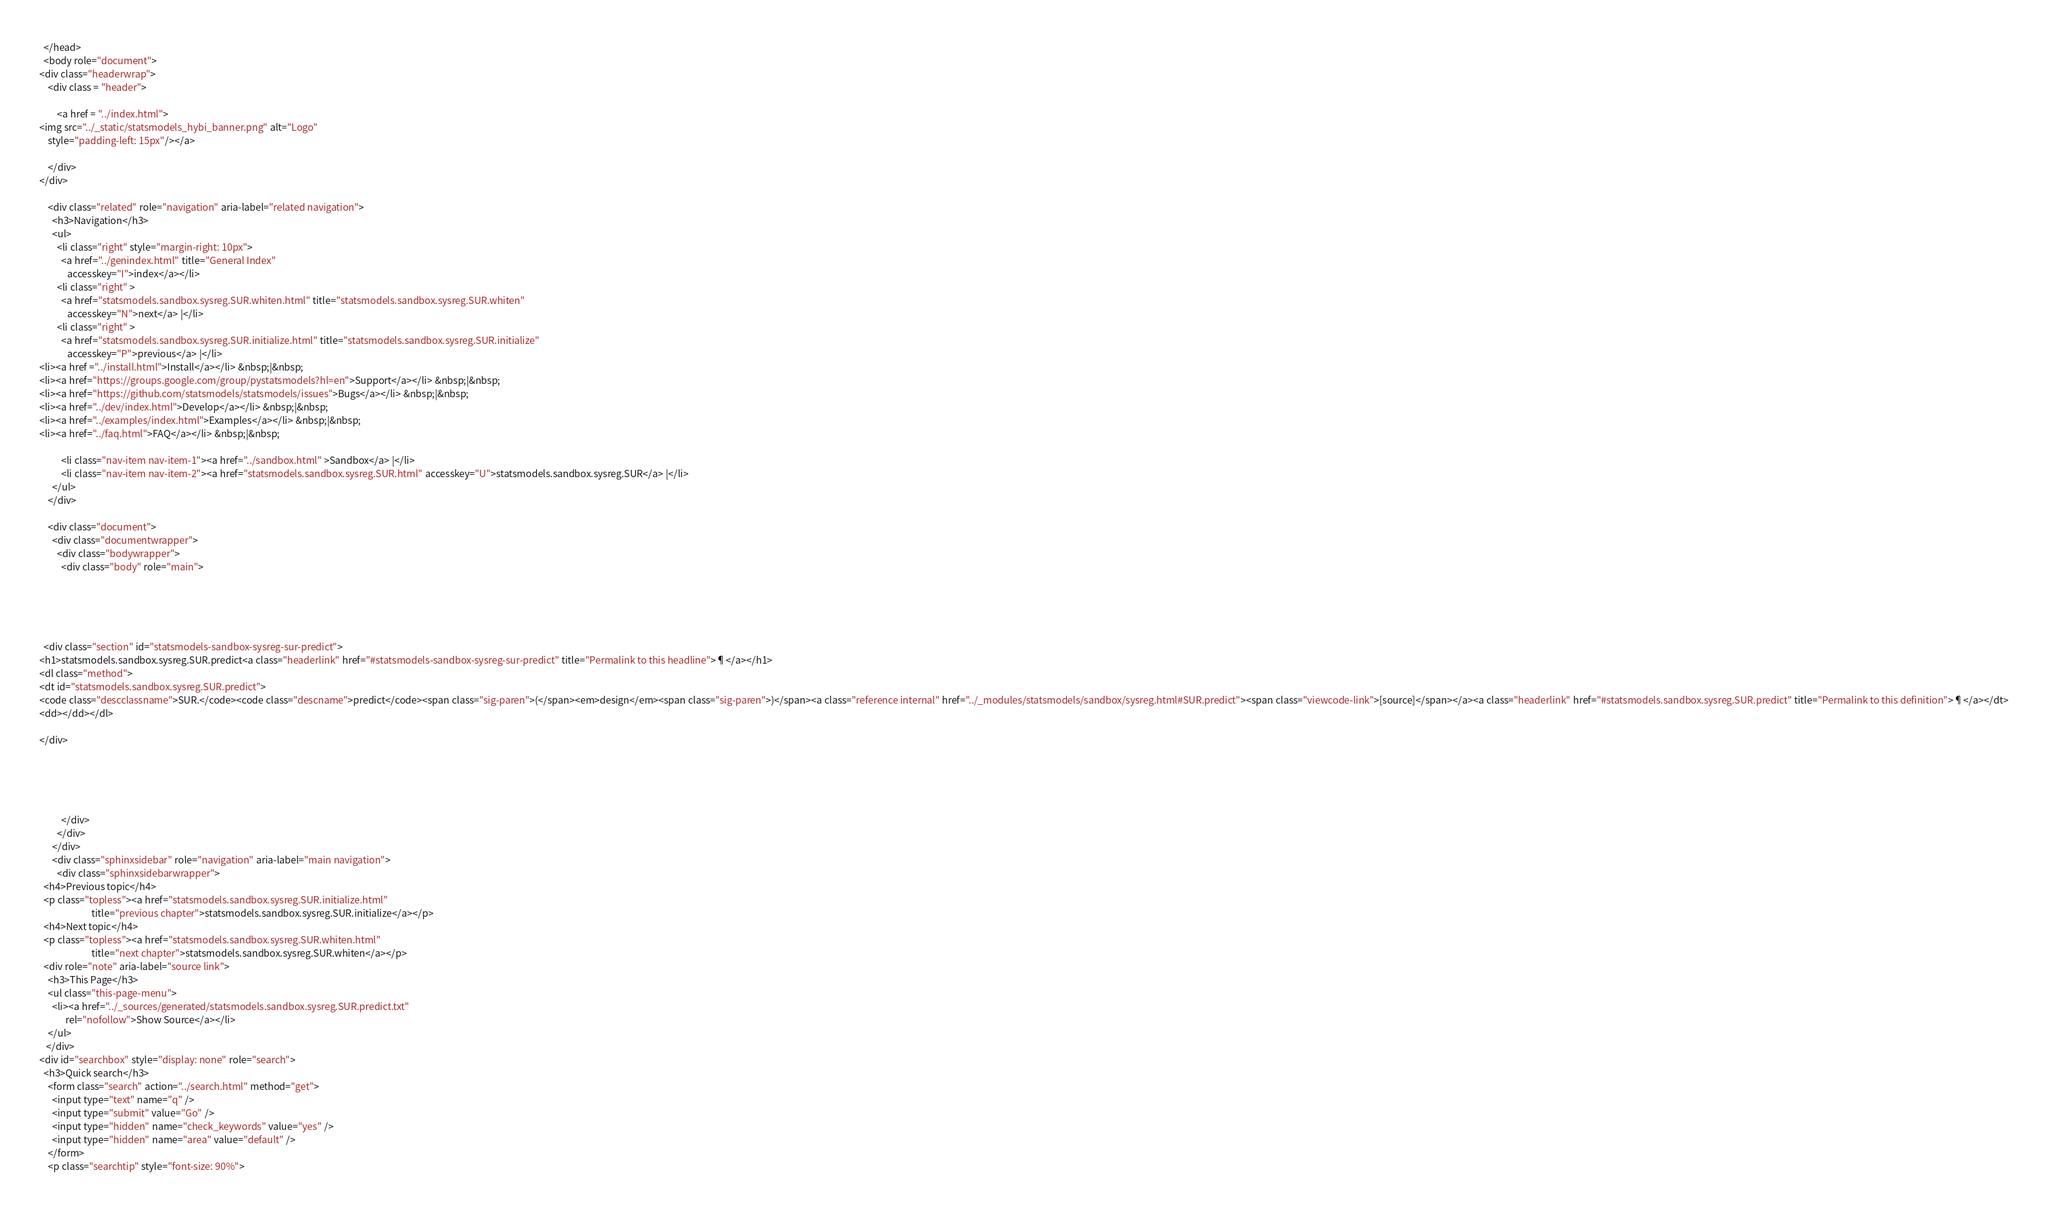<code> <loc_0><loc_0><loc_500><loc_500><_HTML_>
  </head>
  <body role="document">
<div class="headerwrap">
    <div class = "header">
        
        <a href = "../index.html">
<img src="../_static/statsmodels_hybi_banner.png" alt="Logo"
    style="padding-left: 15px"/></a>
        
    </div>
</div>

    <div class="related" role="navigation" aria-label="related navigation">
      <h3>Navigation</h3>
      <ul>
        <li class="right" style="margin-right: 10px">
          <a href="../genindex.html" title="General Index"
             accesskey="I">index</a></li>
        <li class="right" >
          <a href="statsmodels.sandbox.sysreg.SUR.whiten.html" title="statsmodels.sandbox.sysreg.SUR.whiten"
             accesskey="N">next</a> |</li>
        <li class="right" >
          <a href="statsmodels.sandbox.sysreg.SUR.initialize.html" title="statsmodels.sandbox.sysreg.SUR.initialize"
             accesskey="P">previous</a> |</li>
<li><a href ="../install.html">Install</a></li> &nbsp;|&nbsp;
<li><a href="https://groups.google.com/group/pystatsmodels?hl=en">Support</a></li> &nbsp;|&nbsp;
<li><a href="https://github.com/statsmodels/statsmodels/issues">Bugs</a></li> &nbsp;|&nbsp;
<li><a href="../dev/index.html">Develop</a></li> &nbsp;|&nbsp;
<li><a href="../examples/index.html">Examples</a></li> &nbsp;|&nbsp;
<li><a href="../faq.html">FAQ</a></li> &nbsp;|&nbsp;

          <li class="nav-item nav-item-1"><a href="../sandbox.html" >Sandbox</a> |</li>
          <li class="nav-item nav-item-2"><a href="statsmodels.sandbox.sysreg.SUR.html" accesskey="U">statsmodels.sandbox.sysreg.SUR</a> |</li> 
      </ul>
    </div>  

    <div class="document">
      <div class="documentwrapper">
        <div class="bodywrapper">
          <div class="body" role="main">
            




  <div class="section" id="statsmodels-sandbox-sysreg-sur-predict">
<h1>statsmodels.sandbox.sysreg.SUR.predict<a class="headerlink" href="#statsmodels-sandbox-sysreg-sur-predict" title="Permalink to this headline">¶</a></h1>
<dl class="method">
<dt id="statsmodels.sandbox.sysreg.SUR.predict">
<code class="descclassname">SUR.</code><code class="descname">predict</code><span class="sig-paren">(</span><em>design</em><span class="sig-paren">)</span><a class="reference internal" href="../_modules/statsmodels/sandbox/sysreg.html#SUR.predict"><span class="viewcode-link">[source]</span></a><a class="headerlink" href="#statsmodels.sandbox.sysreg.SUR.predict" title="Permalink to this definition">¶</a></dt>
<dd></dd></dl>

</div>





          </div>
        </div>
      </div>
      <div class="sphinxsidebar" role="navigation" aria-label="main navigation">
        <div class="sphinxsidebarwrapper">
  <h4>Previous topic</h4>
  <p class="topless"><a href="statsmodels.sandbox.sysreg.SUR.initialize.html"
                        title="previous chapter">statsmodels.sandbox.sysreg.SUR.initialize</a></p>
  <h4>Next topic</h4>
  <p class="topless"><a href="statsmodels.sandbox.sysreg.SUR.whiten.html"
                        title="next chapter">statsmodels.sandbox.sysreg.SUR.whiten</a></p>
  <div role="note" aria-label="source link">
    <h3>This Page</h3>
    <ul class="this-page-menu">
      <li><a href="../_sources/generated/statsmodels.sandbox.sysreg.SUR.predict.txt"
            rel="nofollow">Show Source</a></li>
    </ul>
   </div>
<div id="searchbox" style="display: none" role="search">
  <h3>Quick search</h3>
    <form class="search" action="../search.html" method="get">
      <input type="text" name="q" />
      <input type="submit" value="Go" />
      <input type="hidden" name="check_keywords" value="yes" />
      <input type="hidden" name="area" value="default" />
    </form>
    <p class="searchtip" style="font-size: 90%"></code> 